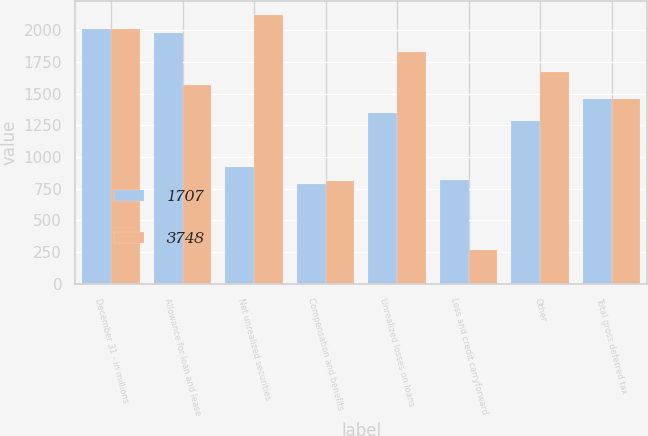Convert chart. <chart><loc_0><loc_0><loc_500><loc_500><stacked_bar_chart><ecel><fcel>December 31 - in millions<fcel>Allowance for loan and lease<fcel>Net unrealized securities<fcel>Compensation and benefits<fcel>Unrealized losses on loans<fcel>Loss and credit carryforward<fcel>Other<fcel>Total gross deferred tax<nl><fcel>1707<fcel>2009<fcel>1978<fcel>922<fcel>788<fcel>1349<fcel>816<fcel>1287<fcel>1456.5<nl><fcel>3748<fcel>2008<fcel>1564<fcel>2121<fcel>813<fcel>1825<fcel>269<fcel>1672<fcel>1456.5<nl></chart> 